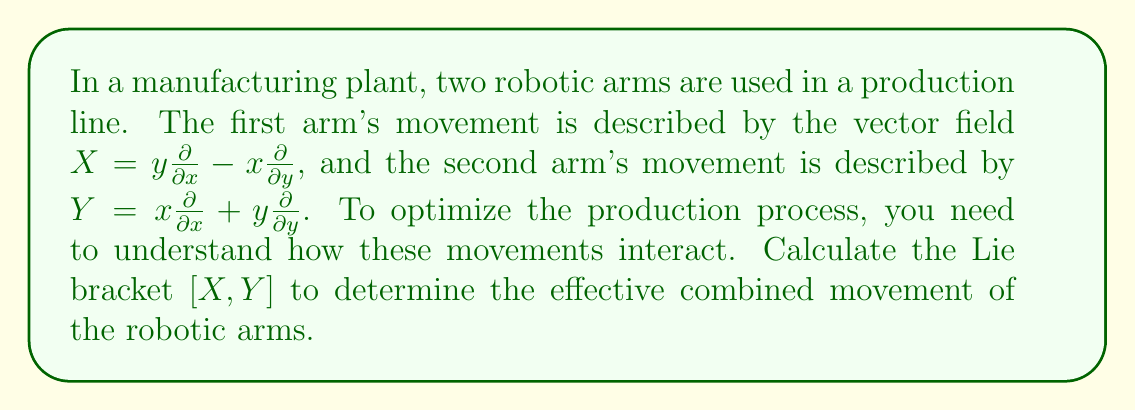Can you answer this question? To solve this problem, we'll follow these steps:

1) Recall the formula for the Lie bracket of two vector fields $X = f_1\frac{\partial}{\partial x} + g_1\frac{\partial}{\partial y}$ and $Y = f_2\frac{\partial}{\partial x} + g_2\frac{\partial}{\partial y}$:

   $$[X,Y] = \left(f_1\frac{\partial f_2}{\partial x} + g_1\frac{\partial f_2}{\partial y} - f_2\frac{\partial f_1}{\partial x} - g_2\frac{\partial f_1}{\partial y}\right)\frac{\partial}{\partial x} + \left(f_1\frac{\partial g_2}{\partial x} + g_1\frac{\partial g_2}{\partial y} - f_2\frac{\partial g_1}{\partial x} - g_2\frac{\partial g_1}{\partial y}\right)\frac{\partial}{\partial y}$$

2) Identify the components of $X$ and $Y$:
   For $X$: $f_1 = y$, $g_1 = -x$
   For $Y$: $f_2 = x$, $g_2 = y$

3) Calculate the partial derivatives:
   $\frac{\partial f_1}{\partial x} = 0$, $\frac{\partial f_1}{\partial y} = 1$
   $\frac{\partial g_1}{\partial x} = -1$, $\frac{\partial g_1}{\partial y} = 0$
   $\frac{\partial f_2}{\partial x} = 1$, $\frac{\partial f_2}{\partial y} = 0$
   $\frac{\partial g_2}{\partial x} = 0$, $\frac{\partial g_2}{\partial y} = 1$

4) Substitute these values into the Lie bracket formula:

   $$[X,Y] = (y\cdot 1 + (-x)\cdot 0 - x\cdot 0 - y\cdot 1)\frac{\partial}{\partial x} + (y\cdot 0 + (-x)\cdot 1 - x\cdot (-1) - y\cdot 0)\frac{\partial}{\partial y}$$

5) Simplify:

   $$[X,Y] = (y - y)\frac{\partial}{\partial x} + (-x + x)\frac{\partial}{\partial y}$$

6) Further simplify:

   $$[X,Y] = 0\frac{\partial}{\partial x} + 0\frac{\partial}{\partial y} = 0$$

This result indicates that the combined effect of the two robotic arm movements, as described by the Lie bracket, cancels out, resulting in no net movement in the production system dynamics.
Answer: $[X,Y] = 0$ 